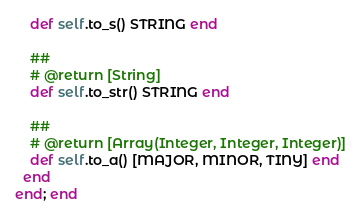<code> <loc_0><loc_0><loc_500><loc_500><_Ruby_>    def self.to_s() STRING end

    ##
    # @return [String]
    def self.to_str() STRING end

    ##
    # @return [Array(Integer, Integer, Integer)]
    def self.to_a() [MAJOR, MINOR, TINY] end
  end
end; end
</code> 